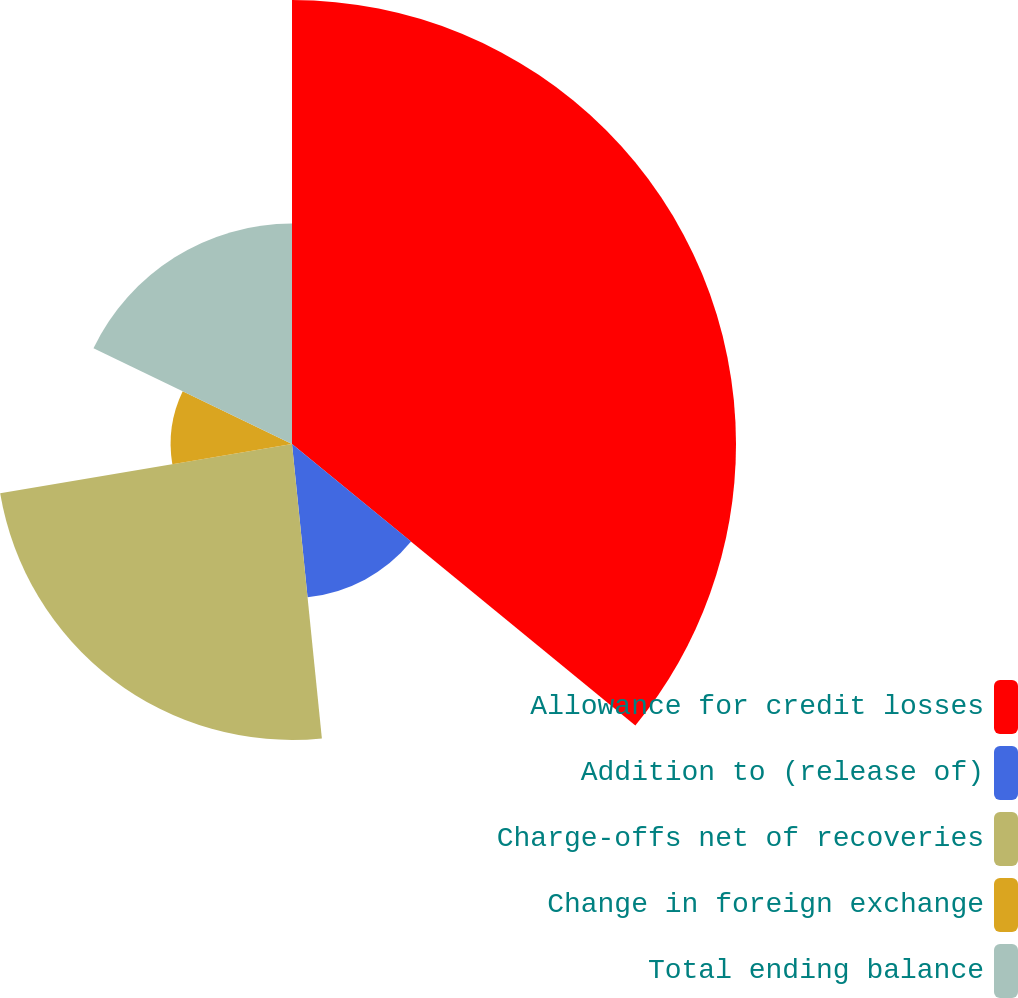Convert chart to OTSL. <chart><loc_0><loc_0><loc_500><loc_500><pie_chart><fcel>Allowance for credit losses<fcel>Addition to (release of)<fcel>Charge-offs net of recoveries<fcel>Change in foreign exchange<fcel>Total ending balance<nl><fcel>35.93%<fcel>12.46%<fcel>23.95%<fcel>9.82%<fcel>17.84%<nl></chart> 